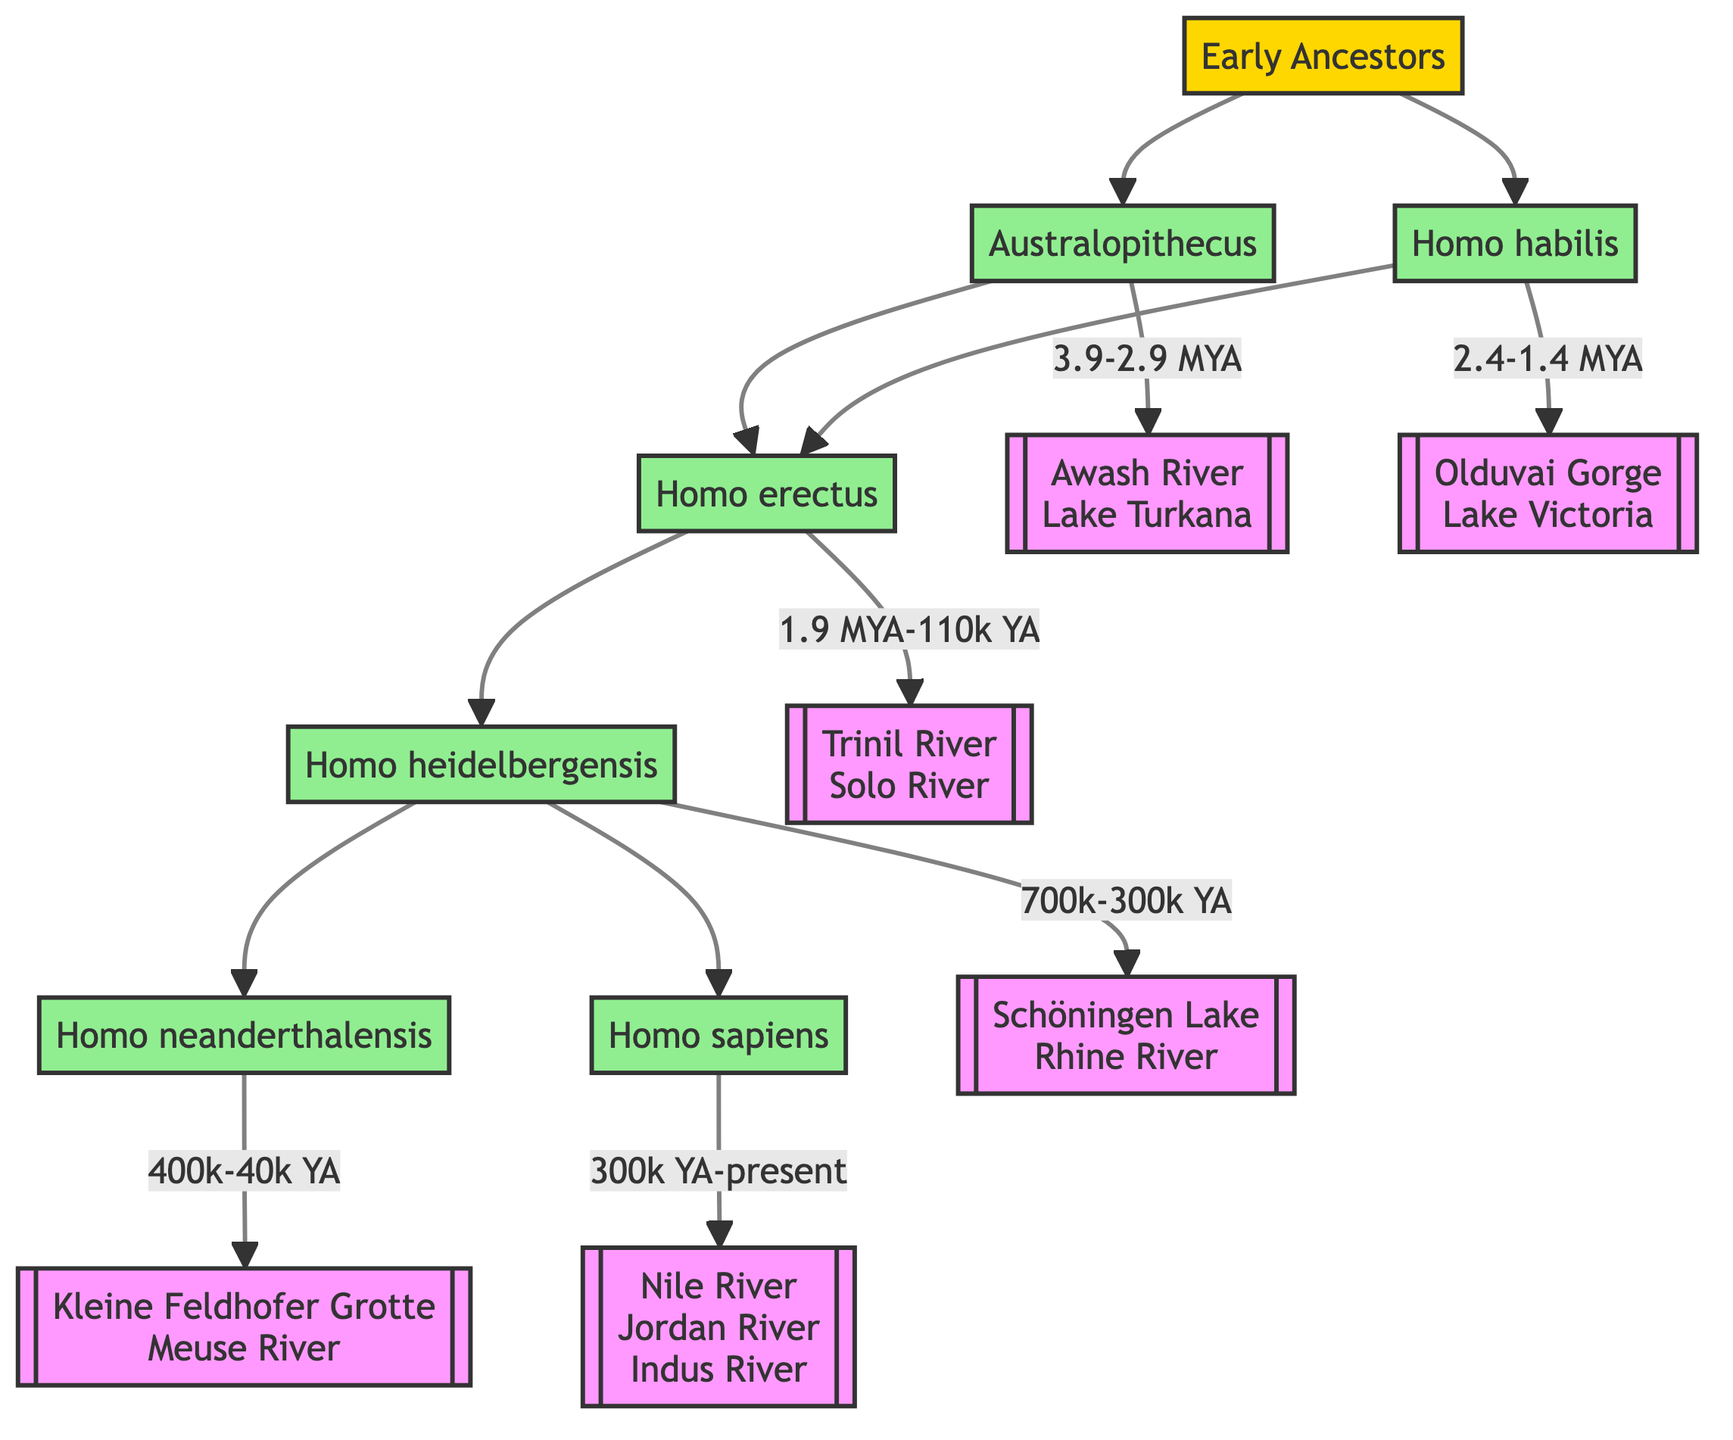What is the species represented by Australopithecus? The diagram states that Australopithecus is represented by Australopithecus afarensis.
Answer: Australopithecus afarensis How many migration patterns are associated with Homo erectus? The diagram shows that Homo erectus has two migration patterns listed: Africa and Asia.
Answer: 2 Which water sources are linked to Homo sapiens? According to the diagram, Homo sapiens are linked to three water sources: Nile River, Jordan River, and Indus River.
Answer: Nile River, Jordan River, Indus River What is the timeline for Homo heidelbergensis? The diagram indicates that the timeline for Homo heidelbergensis is 700,000 to 300,000 years ago.
Answer: 700,000 to 300,000 years ago What is the key location associated with Homo erectus? The diagram states that Dmanisi (Georgia) and Java (Indonesia) are key locations associated with Homo erectus.
Answer: Dmanisi (Georgia), Java (Indonesia) Which species share the same migration pattern with Homo habilis? The diagram shows that Australopithecus shares the same migration pattern (East Africa) with Homo habilis.
Answer: Australopithecus How many total ancestors are shown in the diagram? Counting the nodes in the diagram, there are five ancestors represented: Australopithecus, Homo habilis, Homo erectus, Homo heidelbergensis, and Homo neanderthalensis.
Answer: 5 Which ancestor has migration patterns in Western Asia? The diagram indicates that Homo neanderthalensis is the ancestor with migration patterns in Western Asia.
Answer: Homo neanderthalensis What is the oldest ancestor listed in the diagram? The diagram identifies Australopithecus as the oldest ancestor listed, existing from 3.9 to 2.9 million years ago.
Answer: Australopithecus Which ancestor has the most varied geographical migration patterns? According to the diagram, Homo sapiens has the most varied migration patterns, including Africa, Asia, Europe, and Oceania.
Answer: Homo sapiens 